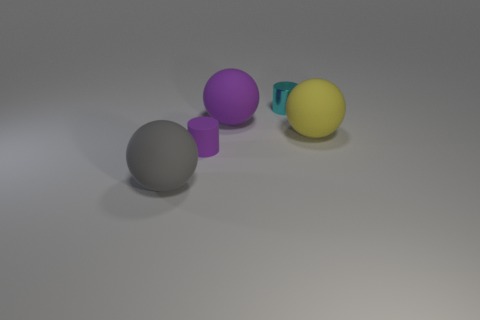Add 4 purple cylinders. How many objects exist? 9 Subtract all purple cylinders. How many cylinders are left? 1 Subtract 0 red spheres. How many objects are left? 5 Subtract all spheres. How many objects are left? 2 Subtract 2 spheres. How many spheres are left? 1 Subtract all cyan cylinders. Subtract all gray balls. How many cylinders are left? 1 Subtract all red balls. How many cyan cylinders are left? 1 Subtract all small metal cylinders. Subtract all cyan things. How many objects are left? 3 Add 2 yellow balls. How many yellow balls are left? 3 Add 4 cyan shiny objects. How many cyan shiny objects exist? 5 